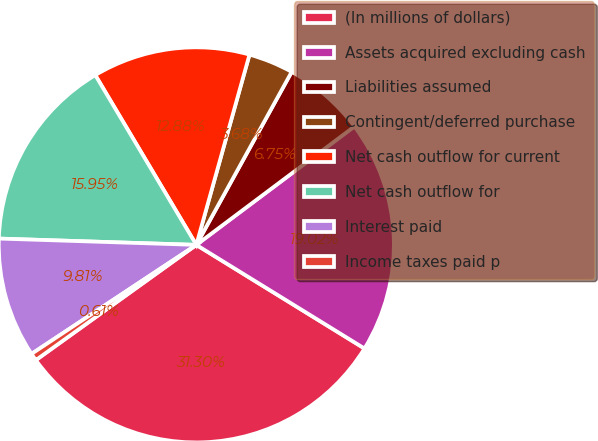Convert chart to OTSL. <chart><loc_0><loc_0><loc_500><loc_500><pie_chart><fcel>(In millions of dollars)<fcel>Assets acquired excluding cash<fcel>Liabilities assumed<fcel>Contingent/deferred purchase<fcel>Net cash outflow for current<fcel>Net cash outflow for<fcel>Interest paid<fcel>Income taxes paid p<nl><fcel>31.3%<fcel>19.02%<fcel>6.75%<fcel>3.68%<fcel>12.88%<fcel>15.95%<fcel>9.81%<fcel>0.61%<nl></chart> 